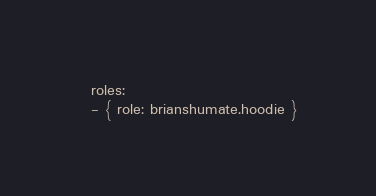Convert code to text. <code><loc_0><loc_0><loc_500><loc_500><_YAML_>  roles:
  - { role: brianshumate.hoodie }
</code> 